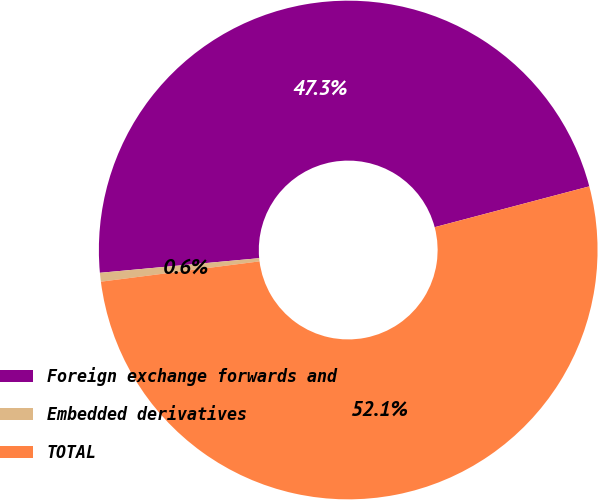Convert chart. <chart><loc_0><loc_0><loc_500><loc_500><pie_chart><fcel>Foreign exchange forwards and<fcel>Embedded derivatives<fcel>TOTAL<nl><fcel>47.35%<fcel>0.57%<fcel>52.08%<nl></chart> 